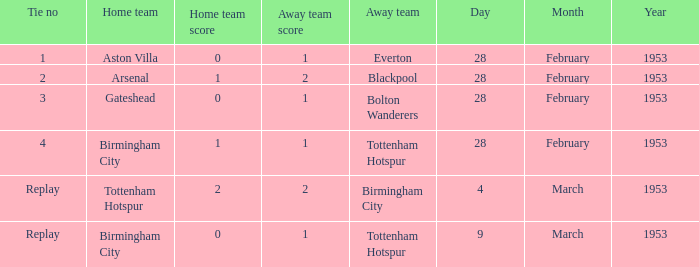Parse the full table. {'header': ['Tie no', 'Home team', 'Home team score', 'Away team score', 'Away team', 'Day', 'Month', 'Year'], 'rows': [['1', 'Aston Villa', '0', '1', 'Everton', '28', 'February', '1953'], ['2', 'Arsenal', '1', '2', 'Blackpool', '28', 'February', '1953'], ['3', 'Gateshead', '0', '1', 'Bolton Wanderers', '28', 'February', '1953'], ['4', 'Birmingham City', '1', '1', 'Tottenham Hotspur', '28', 'February', '1953'], ['Replay', 'Tottenham Hotspur', '2', '2', 'Birmingham City', '4', 'March', '1953'], ['Replay', 'Birmingham City', '0', '1', 'Tottenham Hotspur', '9', 'March', '1953']]} On march 9, 1953, which tie number had a score of 0-1? Replay. 